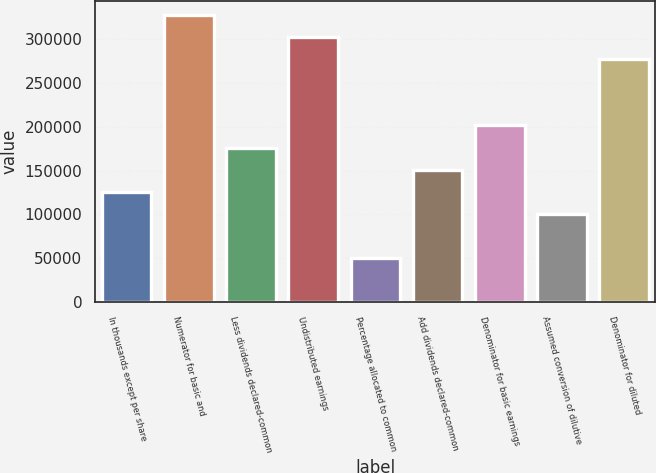<chart> <loc_0><loc_0><loc_500><loc_500><bar_chart><fcel>In thousands except per share<fcel>Numerator for basic and<fcel>Less dividends declared-common<fcel>Undistributed earnings<fcel>Percentage allocated to common<fcel>Add dividends declared-common<fcel>Denominator for basic earnings<fcel>Assumed conversion of dilutive<fcel>Denominator for diluted<nl><fcel>125869<fcel>327250<fcel>176214<fcel>302077<fcel>50350.6<fcel>151041<fcel>201387<fcel>100696<fcel>276905<nl></chart> 